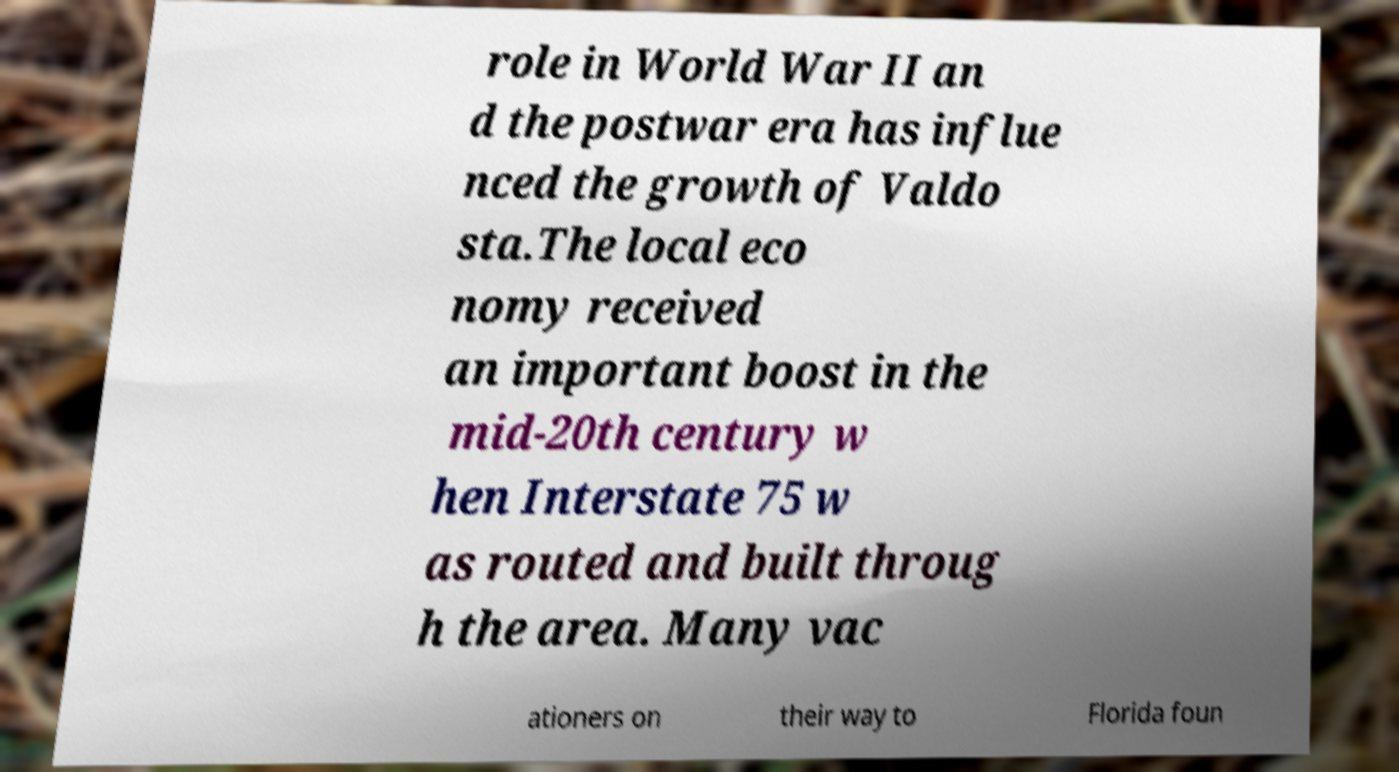Please read and relay the text visible in this image. What does it say? role in World War II an d the postwar era has influe nced the growth of Valdo sta.The local eco nomy received an important boost in the mid-20th century w hen Interstate 75 w as routed and built throug h the area. Many vac ationers on their way to Florida foun 